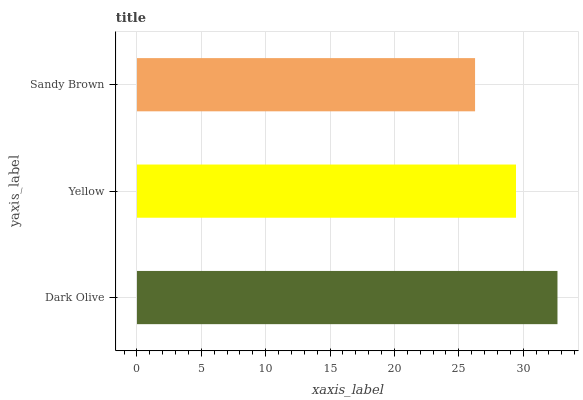Is Sandy Brown the minimum?
Answer yes or no. Yes. Is Dark Olive the maximum?
Answer yes or no. Yes. Is Yellow the minimum?
Answer yes or no. No. Is Yellow the maximum?
Answer yes or no. No. Is Dark Olive greater than Yellow?
Answer yes or no. Yes. Is Yellow less than Dark Olive?
Answer yes or no. Yes. Is Yellow greater than Dark Olive?
Answer yes or no. No. Is Dark Olive less than Yellow?
Answer yes or no. No. Is Yellow the high median?
Answer yes or no. Yes. Is Yellow the low median?
Answer yes or no. Yes. Is Dark Olive the high median?
Answer yes or no. No. Is Dark Olive the low median?
Answer yes or no. No. 